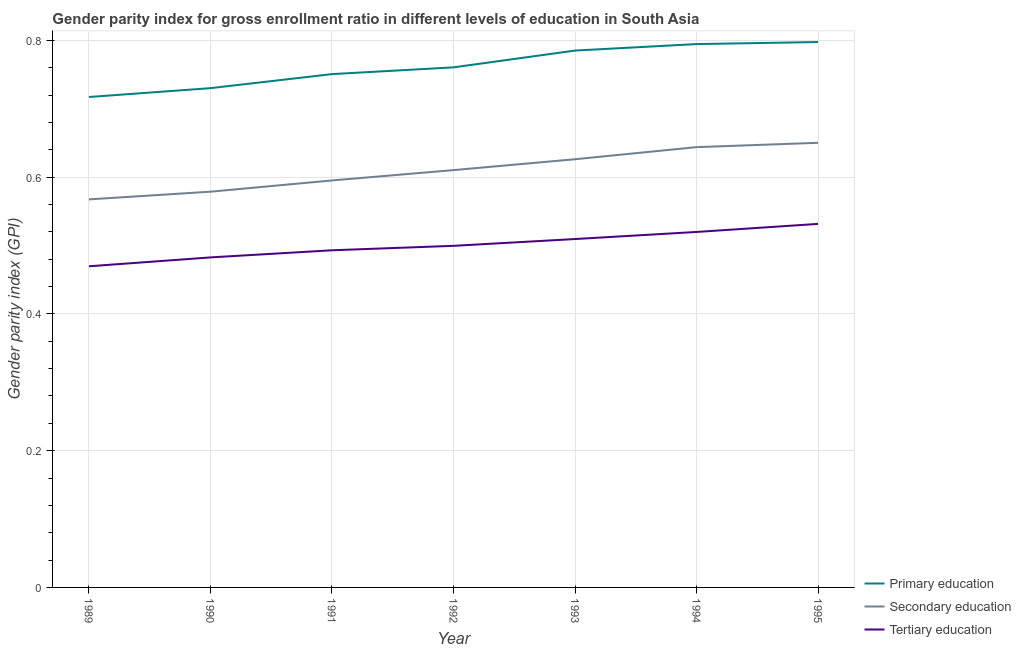How many different coloured lines are there?
Your response must be concise. 3. Does the line corresponding to gender parity index in primary education intersect with the line corresponding to gender parity index in tertiary education?
Your response must be concise. No. Is the number of lines equal to the number of legend labels?
Provide a succinct answer. Yes. What is the gender parity index in secondary education in 1995?
Provide a succinct answer. 0.65. Across all years, what is the maximum gender parity index in secondary education?
Provide a succinct answer. 0.65. Across all years, what is the minimum gender parity index in primary education?
Offer a terse response. 0.72. In which year was the gender parity index in secondary education maximum?
Keep it short and to the point. 1995. What is the total gender parity index in secondary education in the graph?
Make the answer very short. 4.27. What is the difference between the gender parity index in secondary education in 1989 and that in 1995?
Your answer should be very brief. -0.08. What is the difference between the gender parity index in primary education in 1992 and the gender parity index in secondary education in 1991?
Make the answer very short. 0.17. What is the average gender parity index in tertiary education per year?
Provide a succinct answer. 0.5. In the year 1992, what is the difference between the gender parity index in secondary education and gender parity index in primary education?
Provide a succinct answer. -0.15. What is the ratio of the gender parity index in tertiary education in 1991 to that in 1992?
Offer a terse response. 0.99. Is the gender parity index in secondary education in 1989 less than that in 1992?
Provide a short and direct response. Yes. Is the difference between the gender parity index in secondary education in 1990 and 1995 greater than the difference between the gender parity index in tertiary education in 1990 and 1995?
Make the answer very short. No. What is the difference between the highest and the second highest gender parity index in secondary education?
Your answer should be compact. 0.01. What is the difference between the highest and the lowest gender parity index in primary education?
Offer a terse response. 0.08. Is the sum of the gender parity index in primary education in 1989 and 1991 greater than the maximum gender parity index in secondary education across all years?
Your answer should be compact. Yes. Is it the case that in every year, the sum of the gender parity index in primary education and gender parity index in secondary education is greater than the gender parity index in tertiary education?
Give a very brief answer. Yes. Is the gender parity index in secondary education strictly less than the gender parity index in tertiary education over the years?
Provide a succinct answer. No. How many lines are there?
Provide a succinct answer. 3. How many years are there in the graph?
Your response must be concise. 7. How are the legend labels stacked?
Offer a terse response. Vertical. What is the title of the graph?
Provide a succinct answer. Gender parity index for gross enrollment ratio in different levels of education in South Asia. What is the label or title of the X-axis?
Your answer should be very brief. Year. What is the label or title of the Y-axis?
Your answer should be very brief. Gender parity index (GPI). What is the Gender parity index (GPI) in Primary education in 1989?
Your answer should be very brief. 0.72. What is the Gender parity index (GPI) in Secondary education in 1989?
Your answer should be compact. 0.57. What is the Gender parity index (GPI) in Tertiary education in 1989?
Keep it short and to the point. 0.47. What is the Gender parity index (GPI) in Primary education in 1990?
Your response must be concise. 0.73. What is the Gender parity index (GPI) of Secondary education in 1990?
Your answer should be very brief. 0.58. What is the Gender parity index (GPI) in Tertiary education in 1990?
Provide a short and direct response. 0.48. What is the Gender parity index (GPI) of Primary education in 1991?
Provide a succinct answer. 0.75. What is the Gender parity index (GPI) of Secondary education in 1991?
Your response must be concise. 0.6. What is the Gender parity index (GPI) in Tertiary education in 1991?
Offer a very short reply. 0.49. What is the Gender parity index (GPI) in Primary education in 1992?
Your answer should be compact. 0.76. What is the Gender parity index (GPI) of Secondary education in 1992?
Your answer should be very brief. 0.61. What is the Gender parity index (GPI) of Tertiary education in 1992?
Give a very brief answer. 0.5. What is the Gender parity index (GPI) of Primary education in 1993?
Offer a terse response. 0.79. What is the Gender parity index (GPI) in Secondary education in 1993?
Your answer should be compact. 0.63. What is the Gender parity index (GPI) of Tertiary education in 1993?
Ensure brevity in your answer.  0.51. What is the Gender parity index (GPI) in Primary education in 1994?
Provide a short and direct response. 0.79. What is the Gender parity index (GPI) in Secondary education in 1994?
Ensure brevity in your answer.  0.64. What is the Gender parity index (GPI) of Tertiary education in 1994?
Your answer should be very brief. 0.52. What is the Gender parity index (GPI) of Primary education in 1995?
Give a very brief answer. 0.8. What is the Gender parity index (GPI) of Secondary education in 1995?
Provide a short and direct response. 0.65. What is the Gender parity index (GPI) of Tertiary education in 1995?
Offer a very short reply. 0.53. Across all years, what is the maximum Gender parity index (GPI) of Primary education?
Offer a very short reply. 0.8. Across all years, what is the maximum Gender parity index (GPI) in Secondary education?
Provide a succinct answer. 0.65. Across all years, what is the maximum Gender parity index (GPI) in Tertiary education?
Your answer should be very brief. 0.53. Across all years, what is the minimum Gender parity index (GPI) of Primary education?
Your answer should be compact. 0.72. Across all years, what is the minimum Gender parity index (GPI) of Secondary education?
Your response must be concise. 0.57. Across all years, what is the minimum Gender parity index (GPI) in Tertiary education?
Your answer should be very brief. 0.47. What is the total Gender parity index (GPI) in Primary education in the graph?
Provide a short and direct response. 5.34. What is the total Gender parity index (GPI) in Secondary education in the graph?
Offer a very short reply. 4.27. What is the total Gender parity index (GPI) of Tertiary education in the graph?
Your answer should be very brief. 3.51. What is the difference between the Gender parity index (GPI) of Primary education in 1989 and that in 1990?
Your answer should be very brief. -0.01. What is the difference between the Gender parity index (GPI) in Secondary education in 1989 and that in 1990?
Make the answer very short. -0.01. What is the difference between the Gender parity index (GPI) of Tertiary education in 1989 and that in 1990?
Offer a very short reply. -0.01. What is the difference between the Gender parity index (GPI) in Primary education in 1989 and that in 1991?
Offer a terse response. -0.03. What is the difference between the Gender parity index (GPI) of Secondary education in 1989 and that in 1991?
Your answer should be compact. -0.03. What is the difference between the Gender parity index (GPI) in Tertiary education in 1989 and that in 1991?
Keep it short and to the point. -0.02. What is the difference between the Gender parity index (GPI) in Primary education in 1989 and that in 1992?
Provide a short and direct response. -0.04. What is the difference between the Gender parity index (GPI) in Secondary education in 1989 and that in 1992?
Ensure brevity in your answer.  -0.04. What is the difference between the Gender parity index (GPI) of Tertiary education in 1989 and that in 1992?
Your response must be concise. -0.03. What is the difference between the Gender parity index (GPI) of Primary education in 1989 and that in 1993?
Your answer should be compact. -0.07. What is the difference between the Gender parity index (GPI) in Secondary education in 1989 and that in 1993?
Provide a short and direct response. -0.06. What is the difference between the Gender parity index (GPI) of Tertiary education in 1989 and that in 1993?
Your response must be concise. -0.04. What is the difference between the Gender parity index (GPI) of Primary education in 1989 and that in 1994?
Provide a short and direct response. -0.08. What is the difference between the Gender parity index (GPI) in Secondary education in 1989 and that in 1994?
Provide a succinct answer. -0.08. What is the difference between the Gender parity index (GPI) in Tertiary education in 1989 and that in 1994?
Offer a terse response. -0.05. What is the difference between the Gender parity index (GPI) of Primary education in 1989 and that in 1995?
Provide a short and direct response. -0.08. What is the difference between the Gender parity index (GPI) of Secondary education in 1989 and that in 1995?
Provide a short and direct response. -0.08. What is the difference between the Gender parity index (GPI) in Tertiary education in 1989 and that in 1995?
Make the answer very short. -0.06. What is the difference between the Gender parity index (GPI) in Primary education in 1990 and that in 1991?
Offer a very short reply. -0.02. What is the difference between the Gender parity index (GPI) of Secondary education in 1990 and that in 1991?
Make the answer very short. -0.02. What is the difference between the Gender parity index (GPI) of Tertiary education in 1990 and that in 1991?
Ensure brevity in your answer.  -0.01. What is the difference between the Gender parity index (GPI) in Primary education in 1990 and that in 1992?
Provide a short and direct response. -0.03. What is the difference between the Gender parity index (GPI) of Secondary education in 1990 and that in 1992?
Offer a terse response. -0.03. What is the difference between the Gender parity index (GPI) of Tertiary education in 1990 and that in 1992?
Your answer should be compact. -0.02. What is the difference between the Gender parity index (GPI) in Primary education in 1990 and that in 1993?
Offer a very short reply. -0.06. What is the difference between the Gender parity index (GPI) in Secondary education in 1990 and that in 1993?
Give a very brief answer. -0.05. What is the difference between the Gender parity index (GPI) in Tertiary education in 1990 and that in 1993?
Offer a terse response. -0.03. What is the difference between the Gender parity index (GPI) of Primary education in 1990 and that in 1994?
Provide a succinct answer. -0.06. What is the difference between the Gender parity index (GPI) of Secondary education in 1990 and that in 1994?
Ensure brevity in your answer.  -0.07. What is the difference between the Gender parity index (GPI) of Tertiary education in 1990 and that in 1994?
Offer a terse response. -0.04. What is the difference between the Gender parity index (GPI) of Primary education in 1990 and that in 1995?
Your answer should be compact. -0.07. What is the difference between the Gender parity index (GPI) in Secondary education in 1990 and that in 1995?
Your answer should be very brief. -0.07. What is the difference between the Gender parity index (GPI) in Tertiary education in 1990 and that in 1995?
Ensure brevity in your answer.  -0.05. What is the difference between the Gender parity index (GPI) in Primary education in 1991 and that in 1992?
Your answer should be very brief. -0.01. What is the difference between the Gender parity index (GPI) of Secondary education in 1991 and that in 1992?
Offer a terse response. -0.02. What is the difference between the Gender parity index (GPI) in Tertiary education in 1991 and that in 1992?
Offer a terse response. -0.01. What is the difference between the Gender parity index (GPI) of Primary education in 1991 and that in 1993?
Offer a terse response. -0.03. What is the difference between the Gender parity index (GPI) in Secondary education in 1991 and that in 1993?
Keep it short and to the point. -0.03. What is the difference between the Gender parity index (GPI) of Tertiary education in 1991 and that in 1993?
Your response must be concise. -0.02. What is the difference between the Gender parity index (GPI) in Primary education in 1991 and that in 1994?
Ensure brevity in your answer.  -0.04. What is the difference between the Gender parity index (GPI) in Secondary education in 1991 and that in 1994?
Your answer should be very brief. -0.05. What is the difference between the Gender parity index (GPI) of Tertiary education in 1991 and that in 1994?
Keep it short and to the point. -0.03. What is the difference between the Gender parity index (GPI) in Primary education in 1991 and that in 1995?
Ensure brevity in your answer.  -0.05. What is the difference between the Gender parity index (GPI) in Secondary education in 1991 and that in 1995?
Give a very brief answer. -0.06. What is the difference between the Gender parity index (GPI) in Tertiary education in 1991 and that in 1995?
Your answer should be compact. -0.04. What is the difference between the Gender parity index (GPI) in Primary education in 1992 and that in 1993?
Provide a short and direct response. -0.02. What is the difference between the Gender parity index (GPI) in Secondary education in 1992 and that in 1993?
Your answer should be very brief. -0.02. What is the difference between the Gender parity index (GPI) of Tertiary education in 1992 and that in 1993?
Offer a terse response. -0.01. What is the difference between the Gender parity index (GPI) of Primary education in 1992 and that in 1994?
Offer a very short reply. -0.03. What is the difference between the Gender parity index (GPI) in Secondary education in 1992 and that in 1994?
Offer a terse response. -0.03. What is the difference between the Gender parity index (GPI) of Tertiary education in 1992 and that in 1994?
Offer a very short reply. -0.02. What is the difference between the Gender parity index (GPI) in Primary education in 1992 and that in 1995?
Offer a very short reply. -0.04. What is the difference between the Gender parity index (GPI) in Secondary education in 1992 and that in 1995?
Ensure brevity in your answer.  -0.04. What is the difference between the Gender parity index (GPI) in Tertiary education in 1992 and that in 1995?
Offer a terse response. -0.03. What is the difference between the Gender parity index (GPI) of Primary education in 1993 and that in 1994?
Keep it short and to the point. -0.01. What is the difference between the Gender parity index (GPI) of Secondary education in 1993 and that in 1994?
Your answer should be very brief. -0.02. What is the difference between the Gender parity index (GPI) of Tertiary education in 1993 and that in 1994?
Make the answer very short. -0.01. What is the difference between the Gender parity index (GPI) of Primary education in 1993 and that in 1995?
Provide a succinct answer. -0.01. What is the difference between the Gender parity index (GPI) of Secondary education in 1993 and that in 1995?
Make the answer very short. -0.02. What is the difference between the Gender parity index (GPI) of Tertiary education in 1993 and that in 1995?
Offer a very short reply. -0.02. What is the difference between the Gender parity index (GPI) in Primary education in 1994 and that in 1995?
Offer a terse response. -0. What is the difference between the Gender parity index (GPI) of Secondary education in 1994 and that in 1995?
Provide a succinct answer. -0.01. What is the difference between the Gender parity index (GPI) in Tertiary education in 1994 and that in 1995?
Provide a short and direct response. -0.01. What is the difference between the Gender parity index (GPI) of Primary education in 1989 and the Gender parity index (GPI) of Secondary education in 1990?
Provide a short and direct response. 0.14. What is the difference between the Gender parity index (GPI) in Primary education in 1989 and the Gender parity index (GPI) in Tertiary education in 1990?
Ensure brevity in your answer.  0.23. What is the difference between the Gender parity index (GPI) in Secondary education in 1989 and the Gender parity index (GPI) in Tertiary education in 1990?
Your response must be concise. 0.08. What is the difference between the Gender parity index (GPI) of Primary education in 1989 and the Gender parity index (GPI) of Secondary education in 1991?
Your response must be concise. 0.12. What is the difference between the Gender parity index (GPI) of Primary education in 1989 and the Gender parity index (GPI) of Tertiary education in 1991?
Provide a short and direct response. 0.22. What is the difference between the Gender parity index (GPI) of Secondary education in 1989 and the Gender parity index (GPI) of Tertiary education in 1991?
Your answer should be very brief. 0.07. What is the difference between the Gender parity index (GPI) of Primary education in 1989 and the Gender parity index (GPI) of Secondary education in 1992?
Offer a very short reply. 0.11. What is the difference between the Gender parity index (GPI) of Primary education in 1989 and the Gender parity index (GPI) of Tertiary education in 1992?
Ensure brevity in your answer.  0.22. What is the difference between the Gender parity index (GPI) in Secondary education in 1989 and the Gender parity index (GPI) in Tertiary education in 1992?
Keep it short and to the point. 0.07. What is the difference between the Gender parity index (GPI) of Primary education in 1989 and the Gender parity index (GPI) of Secondary education in 1993?
Offer a very short reply. 0.09. What is the difference between the Gender parity index (GPI) of Primary education in 1989 and the Gender parity index (GPI) of Tertiary education in 1993?
Ensure brevity in your answer.  0.21. What is the difference between the Gender parity index (GPI) of Secondary education in 1989 and the Gender parity index (GPI) of Tertiary education in 1993?
Your response must be concise. 0.06. What is the difference between the Gender parity index (GPI) in Primary education in 1989 and the Gender parity index (GPI) in Secondary education in 1994?
Make the answer very short. 0.07. What is the difference between the Gender parity index (GPI) in Primary education in 1989 and the Gender parity index (GPI) in Tertiary education in 1994?
Offer a terse response. 0.2. What is the difference between the Gender parity index (GPI) of Secondary education in 1989 and the Gender parity index (GPI) of Tertiary education in 1994?
Keep it short and to the point. 0.05. What is the difference between the Gender parity index (GPI) of Primary education in 1989 and the Gender parity index (GPI) of Secondary education in 1995?
Your answer should be very brief. 0.07. What is the difference between the Gender parity index (GPI) in Primary education in 1989 and the Gender parity index (GPI) in Tertiary education in 1995?
Provide a succinct answer. 0.19. What is the difference between the Gender parity index (GPI) in Secondary education in 1989 and the Gender parity index (GPI) in Tertiary education in 1995?
Provide a short and direct response. 0.04. What is the difference between the Gender parity index (GPI) of Primary education in 1990 and the Gender parity index (GPI) of Secondary education in 1991?
Offer a very short reply. 0.14. What is the difference between the Gender parity index (GPI) in Primary education in 1990 and the Gender parity index (GPI) in Tertiary education in 1991?
Your response must be concise. 0.24. What is the difference between the Gender parity index (GPI) of Secondary education in 1990 and the Gender parity index (GPI) of Tertiary education in 1991?
Make the answer very short. 0.09. What is the difference between the Gender parity index (GPI) of Primary education in 1990 and the Gender parity index (GPI) of Secondary education in 1992?
Your response must be concise. 0.12. What is the difference between the Gender parity index (GPI) of Primary education in 1990 and the Gender parity index (GPI) of Tertiary education in 1992?
Your response must be concise. 0.23. What is the difference between the Gender parity index (GPI) in Secondary education in 1990 and the Gender parity index (GPI) in Tertiary education in 1992?
Ensure brevity in your answer.  0.08. What is the difference between the Gender parity index (GPI) of Primary education in 1990 and the Gender parity index (GPI) of Secondary education in 1993?
Give a very brief answer. 0.1. What is the difference between the Gender parity index (GPI) of Primary education in 1990 and the Gender parity index (GPI) of Tertiary education in 1993?
Provide a succinct answer. 0.22. What is the difference between the Gender parity index (GPI) of Secondary education in 1990 and the Gender parity index (GPI) of Tertiary education in 1993?
Make the answer very short. 0.07. What is the difference between the Gender parity index (GPI) of Primary education in 1990 and the Gender parity index (GPI) of Secondary education in 1994?
Ensure brevity in your answer.  0.09. What is the difference between the Gender parity index (GPI) of Primary education in 1990 and the Gender parity index (GPI) of Tertiary education in 1994?
Offer a terse response. 0.21. What is the difference between the Gender parity index (GPI) in Secondary education in 1990 and the Gender parity index (GPI) in Tertiary education in 1994?
Give a very brief answer. 0.06. What is the difference between the Gender parity index (GPI) in Primary education in 1990 and the Gender parity index (GPI) in Secondary education in 1995?
Keep it short and to the point. 0.08. What is the difference between the Gender parity index (GPI) in Primary education in 1990 and the Gender parity index (GPI) in Tertiary education in 1995?
Your response must be concise. 0.2. What is the difference between the Gender parity index (GPI) in Secondary education in 1990 and the Gender parity index (GPI) in Tertiary education in 1995?
Your answer should be very brief. 0.05. What is the difference between the Gender parity index (GPI) of Primary education in 1991 and the Gender parity index (GPI) of Secondary education in 1992?
Keep it short and to the point. 0.14. What is the difference between the Gender parity index (GPI) of Primary education in 1991 and the Gender parity index (GPI) of Tertiary education in 1992?
Provide a succinct answer. 0.25. What is the difference between the Gender parity index (GPI) in Secondary education in 1991 and the Gender parity index (GPI) in Tertiary education in 1992?
Your answer should be compact. 0.1. What is the difference between the Gender parity index (GPI) in Primary education in 1991 and the Gender parity index (GPI) in Secondary education in 1993?
Your answer should be very brief. 0.12. What is the difference between the Gender parity index (GPI) in Primary education in 1991 and the Gender parity index (GPI) in Tertiary education in 1993?
Your response must be concise. 0.24. What is the difference between the Gender parity index (GPI) in Secondary education in 1991 and the Gender parity index (GPI) in Tertiary education in 1993?
Offer a terse response. 0.09. What is the difference between the Gender parity index (GPI) of Primary education in 1991 and the Gender parity index (GPI) of Secondary education in 1994?
Offer a very short reply. 0.11. What is the difference between the Gender parity index (GPI) in Primary education in 1991 and the Gender parity index (GPI) in Tertiary education in 1994?
Provide a short and direct response. 0.23. What is the difference between the Gender parity index (GPI) in Secondary education in 1991 and the Gender parity index (GPI) in Tertiary education in 1994?
Give a very brief answer. 0.08. What is the difference between the Gender parity index (GPI) of Primary education in 1991 and the Gender parity index (GPI) of Secondary education in 1995?
Your response must be concise. 0.1. What is the difference between the Gender parity index (GPI) in Primary education in 1991 and the Gender parity index (GPI) in Tertiary education in 1995?
Your response must be concise. 0.22. What is the difference between the Gender parity index (GPI) of Secondary education in 1991 and the Gender parity index (GPI) of Tertiary education in 1995?
Offer a very short reply. 0.06. What is the difference between the Gender parity index (GPI) of Primary education in 1992 and the Gender parity index (GPI) of Secondary education in 1993?
Give a very brief answer. 0.13. What is the difference between the Gender parity index (GPI) in Primary education in 1992 and the Gender parity index (GPI) in Tertiary education in 1993?
Offer a terse response. 0.25. What is the difference between the Gender parity index (GPI) of Secondary education in 1992 and the Gender parity index (GPI) of Tertiary education in 1993?
Offer a terse response. 0.1. What is the difference between the Gender parity index (GPI) in Primary education in 1992 and the Gender parity index (GPI) in Secondary education in 1994?
Your answer should be very brief. 0.12. What is the difference between the Gender parity index (GPI) in Primary education in 1992 and the Gender parity index (GPI) in Tertiary education in 1994?
Make the answer very short. 0.24. What is the difference between the Gender parity index (GPI) of Secondary education in 1992 and the Gender parity index (GPI) of Tertiary education in 1994?
Offer a terse response. 0.09. What is the difference between the Gender parity index (GPI) in Primary education in 1992 and the Gender parity index (GPI) in Secondary education in 1995?
Give a very brief answer. 0.11. What is the difference between the Gender parity index (GPI) in Primary education in 1992 and the Gender parity index (GPI) in Tertiary education in 1995?
Offer a terse response. 0.23. What is the difference between the Gender parity index (GPI) of Secondary education in 1992 and the Gender parity index (GPI) of Tertiary education in 1995?
Offer a very short reply. 0.08. What is the difference between the Gender parity index (GPI) in Primary education in 1993 and the Gender parity index (GPI) in Secondary education in 1994?
Offer a terse response. 0.14. What is the difference between the Gender parity index (GPI) in Primary education in 1993 and the Gender parity index (GPI) in Tertiary education in 1994?
Give a very brief answer. 0.27. What is the difference between the Gender parity index (GPI) in Secondary education in 1993 and the Gender parity index (GPI) in Tertiary education in 1994?
Ensure brevity in your answer.  0.11. What is the difference between the Gender parity index (GPI) in Primary education in 1993 and the Gender parity index (GPI) in Secondary education in 1995?
Your answer should be very brief. 0.13. What is the difference between the Gender parity index (GPI) of Primary education in 1993 and the Gender parity index (GPI) of Tertiary education in 1995?
Provide a short and direct response. 0.25. What is the difference between the Gender parity index (GPI) of Secondary education in 1993 and the Gender parity index (GPI) of Tertiary education in 1995?
Make the answer very short. 0.09. What is the difference between the Gender parity index (GPI) in Primary education in 1994 and the Gender parity index (GPI) in Secondary education in 1995?
Give a very brief answer. 0.14. What is the difference between the Gender parity index (GPI) of Primary education in 1994 and the Gender parity index (GPI) of Tertiary education in 1995?
Offer a terse response. 0.26. What is the difference between the Gender parity index (GPI) in Secondary education in 1994 and the Gender parity index (GPI) in Tertiary education in 1995?
Provide a short and direct response. 0.11. What is the average Gender parity index (GPI) in Primary education per year?
Your answer should be compact. 0.76. What is the average Gender parity index (GPI) in Secondary education per year?
Your response must be concise. 0.61. What is the average Gender parity index (GPI) of Tertiary education per year?
Your answer should be very brief. 0.5. In the year 1989, what is the difference between the Gender parity index (GPI) of Primary education and Gender parity index (GPI) of Secondary education?
Your answer should be very brief. 0.15. In the year 1989, what is the difference between the Gender parity index (GPI) of Primary education and Gender parity index (GPI) of Tertiary education?
Ensure brevity in your answer.  0.25. In the year 1989, what is the difference between the Gender parity index (GPI) in Secondary education and Gender parity index (GPI) in Tertiary education?
Make the answer very short. 0.1. In the year 1990, what is the difference between the Gender parity index (GPI) of Primary education and Gender parity index (GPI) of Secondary education?
Make the answer very short. 0.15. In the year 1990, what is the difference between the Gender parity index (GPI) of Primary education and Gender parity index (GPI) of Tertiary education?
Keep it short and to the point. 0.25. In the year 1990, what is the difference between the Gender parity index (GPI) in Secondary education and Gender parity index (GPI) in Tertiary education?
Give a very brief answer. 0.1. In the year 1991, what is the difference between the Gender parity index (GPI) in Primary education and Gender parity index (GPI) in Secondary education?
Offer a terse response. 0.16. In the year 1991, what is the difference between the Gender parity index (GPI) in Primary education and Gender parity index (GPI) in Tertiary education?
Give a very brief answer. 0.26. In the year 1991, what is the difference between the Gender parity index (GPI) in Secondary education and Gender parity index (GPI) in Tertiary education?
Give a very brief answer. 0.1. In the year 1992, what is the difference between the Gender parity index (GPI) of Primary education and Gender parity index (GPI) of Secondary education?
Give a very brief answer. 0.15. In the year 1992, what is the difference between the Gender parity index (GPI) of Primary education and Gender parity index (GPI) of Tertiary education?
Offer a very short reply. 0.26. In the year 1992, what is the difference between the Gender parity index (GPI) of Secondary education and Gender parity index (GPI) of Tertiary education?
Give a very brief answer. 0.11. In the year 1993, what is the difference between the Gender parity index (GPI) of Primary education and Gender parity index (GPI) of Secondary education?
Offer a very short reply. 0.16. In the year 1993, what is the difference between the Gender parity index (GPI) in Primary education and Gender parity index (GPI) in Tertiary education?
Offer a terse response. 0.28. In the year 1993, what is the difference between the Gender parity index (GPI) of Secondary education and Gender parity index (GPI) of Tertiary education?
Make the answer very short. 0.12. In the year 1994, what is the difference between the Gender parity index (GPI) in Primary education and Gender parity index (GPI) in Secondary education?
Your answer should be compact. 0.15. In the year 1994, what is the difference between the Gender parity index (GPI) of Primary education and Gender parity index (GPI) of Tertiary education?
Keep it short and to the point. 0.27. In the year 1994, what is the difference between the Gender parity index (GPI) in Secondary education and Gender parity index (GPI) in Tertiary education?
Offer a terse response. 0.12. In the year 1995, what is the difference between the Gender parity index (GPI) in Primary education and Gender parity index (GPI) in Secondary education?
Your response must be concise. 0.15. In the year 1995, what is the difference between the Gender parity index (GPI) in Primary education and Gender parity index (GPI) in Tertiary education?
Provide a short and direct response. 0.27. In the year 1995, what is the difference between the Gender parity index (GPI) of Secondary education and Gender parity index (GPI) of Tertiary education?
Provide a short and direct response. 0.12. What is the ratio of the Gender parity index (GPI) in Primary education in 1989 to that in 1990?
Provide a succinct answer. 0.98. What is the ratio of the Gender parity index (GPI) in Secondary education in 1989 to that in 1990?
Your response must be concise. 0.98. What is the ratio of the Gender parity index (GPI) of Tertiary education in 1989 to that in 1990?
Keep it short and to the point. 0.97. What is the ratio of the Gender parity index (GPI) in Primary education in 1989 to that in 1991?
Offer a very short reply. 0.96. What is the ratio of the Gender parity index (GPI) of Secondary education in 1989 to that in 1991?
Your response must be concise. 0.95. What is the ratio of the Gender parity index (GPI) in Tertiary education in 1989 to that in 1991?
Keep it short and to the point. 0.95. What is the ratio of the Gender parity index (GPI) of Primary education in 1989 to that in 1992?
Offer a very short reply. 0.94. What is the ratio of the Gender parity index (GPI) of Secondary education in 1989 to that in 1992?
Make the answer very short. 0.93. What is the ratio of the Gender parity index (GPI) of Tertiary education in 1989 to that in 1992?
Your answer should be very brief. 0.94. What is the ratio of the Gender parity index (GPI) of Primary education in 1989 to that in 1993?
Offer a very short reply. 0.91. What is the ratio of the Gender parity index (GPI) of Secondary education in 1989 to that in 1993?
Make the answer very short. 0.91. What is the ratio of the Gender parity index (GPI) in Tertiary education in 1989 to that in 1993?
Make the answer very short. 0.92. What is the ratio of the Gender parity index (GPI) in Primary education in 1989 to that in 1994?
Ensure brevity in your answer.  0.9. What is the ratio of the Gender parity index (GPI) in Secondary education in 1989 to that in 1994?
Make the answer very short. 0.88. What is the ratio of the Gender parity index (GPI) in Tertiary education in 1989 to that in 1994?
Ensure brevity in your answer.  0.9. What is the ratio of the Gender parity index (GPI) in Primary education in 1989 to that in 1995?
Make the answer very short. 0.9. What is the ratio of the Gender parity index (GPI) in Secondary education in 1989 to that in 1995?
Make the answer very short. 0.87. What is the ratio of the Gender parity index (GPI) of Tertiary education in 1989 to that in 1995?
Offer a very short reply. 0.88. What is the ratio of the Gender parity index (GPI) of Primary education in 1990 to that in 1991?
Provide a short and direct response. 0.97. What is the ratio of the Gender parity index (GPI) of Secondary education in 1990 to that in 1991?
Ensure brevity in your answer.  0.97. What is the ratio of the Gender parity index (GPI) of Tertiary education in 1990 to that in 1991?
Provide a short and direct response. 0.98. What is the ratio of the Gender parity index (GPI) in Primary education in 1990 to that in 1992?
Ensure brevity in your answer.  0.96. What is the ratio of the Gender parity index (GPI) of Secondary education in 1990 to that in 1992?
Ensure brevity in your answer.  0.95. What is the ratio of the Gender parity index (GPI) of Tertiary education in 1990 to that in 1992?
Keep it short and to the point. 0.97. What is the ratio of the Gender parity index (GPI) in Secondary education in 1990 to that in 1993?
Provide a short and direct response. 0.92. What is the ratio of the Gender parity index (GPI) in Tertiary education in 1990 to that in 1993?
Give a very brief answer. 0.95. What is the ratio of the Gender parity index (GPI) of Primary education in 1990 to that in 1994?
Your answer should be compact. 0.92. What is the ratio of the Gender parity index (GPI) in Secondary education in 1990 to that in 1994?
Your answer should be compact. 0.9. What is the ratio of the Gender parity index (GPI) of Tertiary education in 1990 to that in 1994?
Provide a short and direct response. 0.93. What is the ratio of the Gender parity index (GPI) in Primary education in 1990 to that in 1995?
Your response must be concise. 0.92. What is the ratio of the Gender parity index (GPI) in Secondary education in 1990 to that in 1995?
Your answer should be compact. 0.89. What is the ratio of the Gender parity index (GPI) in Tertiary education in 1990 to that in 1995?
Your answer should be very brief. 0.91. What is the ratio of the Gender parity index (GPI) of Primary education in 1991 to that in 1992?
Keep it short and to the point. 0.99. What is the ratio of the Gender parity index (GPI) in Secondary education in 1991 to that in 1992?
Ensure brevity in your answer.  0.98. What is the ratio of the Gender parity index (GPI) of Tertiary education in 1991 to that in 1992?
Offer a very short reply. 0.99. What is the ratio of the Gender parity index (GPI) in Primary education in 1991 to that in 1993?
Give a very brief answer. 0.96. What is the ratio of the Gender parity index (GPI) of Secondary education in 1991 to that in 1993?
Ensure brevity in your answer.  0.95. What is the ratio of the Gender parity index (GPI) of Tertiary education in 1991 to that in 1993?
Your response must be concise. 0.97. What is the ratio of the Gender parity index (GPI) of Primary education in 1991 to that in 1994?
Offer a very short reply. 0.94. What is the ratio of the Gender parity index (GPI) of Secondary education in 1991 to that in 1994?
Your response must be concise. 0.92. What is the ratio of the Gender parity index (GPI) of Tertiary education in 1991 to that in 1994?
Keep it short and to the point. 0.95. What is the ratio of the Gender parity index (GPI) in Secondary education in 1991 to that in 1995?
Your answer should be very brief. 0.92. What is the ratio of the Gender parity index (GPI) in Tertiary education in 1991 to that in 1995?
Offer a terse response. 0.93. What is the ratio of the Gender parity index (GPI) of Primary education in 1992 to that in 1993?
Offer a very short reply. 0.97. What is the ratio of the Gender parity index (GPI) in Secondary education in 1992 to that in 1993?
Your answer should be very brief. 0.97. What is the ratio of the Gender parity index (GPI) of Tertiary education in 1992 to that in 1993?
Offer a terse response. 0.98. What is the ratio of the Gender parity index (GPI) of Primary education in 1992 to that in 1994?
Provide a short and direct response. 0.96. What is the ratio of the Gender parity index (GPI) in Secondary education in 1992 to that in 1994?
Give a very brief answer. 0.95. What is the ratio of the Gender parity index (GPI) in Tertiary education in 1992 to that in 1994?
Provide a succinct answer. 0.96. What is the ratio of the Gender parity index (GPI) of Primary education in 1992 to that in 1995?
Ensure brevity in your answer.  0.95. What is the ratio of the Gender parity index (GPI) of Secondary education in 1992 to that in 1995?
Provide a succinct answer. 0.94. What is the ratio of the Gender parity index (GPI) of Tertiary education in 1992 to that in 1995?
Offer a very short reply. 0.94. What is the ratio of the Gender parity index (GPI) in Primary education in 1993 to that in 1994?
Offer a terse response. 0.99. What is the ratio of the Gender parity index (GPI) in Secondary education in 1993 to that in 1994?
Ensure brevity in your answer.  0.97. What is the ratio of the Gender parity index (GPI) in Tertiary education in 1993 to that in 1994?
Ensure brevity in your answer.  0.98. What is the ratio of the Gender parity index (GPI) in Primary education in 1993 to that in 1995?
Offer a terse response. 0.98. What is the ratio of the Gender parity index (GPI) of Tertiary education in 1993 to that in 1995?
Keep it short and to the point. 0.96. What is the ratio of the Gender parity index (GPI) in Primary education in 1994 to that in 1995?
Make the answer very short. 1. What is the ratio of the Gender parity index (GPI) in Secondary education in 1994 to that in 1995?
Your response must be concise. 0.99. What is the ratio of the Gender parity index (GPI) of Tertiary education in 1994 to that in 1995?
Your answer should be very brief. 0.98. What is the difference between the highest and the second highest Gender parity index (GPI) of Primary education?
Your answer should be compact. 0. What is the difference between the highest and the second highest Gender parity index (GPI) in Secondary education?
Offer a very short reply. 0.01. What is the difference between the highest and the second highest Gender parity index (GPI) of Tertiary education?
Give a very brief answer. 0.01. What is the difference between the highest and the lowest Gender parity index (GPI) of Primary education?
Ensure brevity in your answer.  0.08. What is the difference between the highest and the lowest Gender parity index (GPI) in Secondary education?
Your answer should be very brief. 0.08. What is the difference between the highest and the lowest Gender parity index (GPI) of Tertiary education?
Your answer should be very brief. 0.06. 